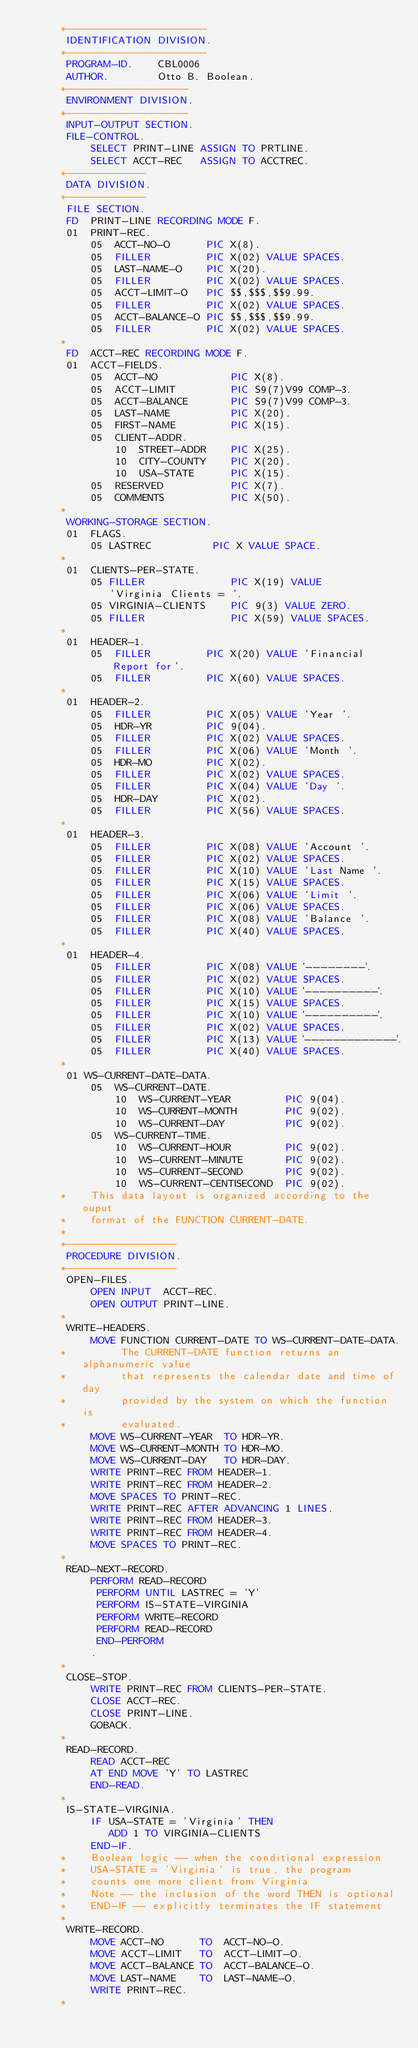Convert code to text. <code><loc_0><loc_0><loc_500><loc_500><_COBOL_>      *-----------------------
       IDENTIFICATION DIVISION.
      *-----------------------
       PROGRAM-ID.    CBL0006
       AUTHOR.        Otto B. Boolean.
      *--------------------
       ENVIRONMENT DIVISION.
      *--------------------
       INPUT-OUTPUT SECTION.
       FILE-CONTROL.
           SELECT PRINT-LINE ASSIGN TO PRTLINE.
           SELECT ACCT-REC   ASSIGN TO ACCTREC.
      *-------------
       DATA DIVISION.
      *-------------
       FILE SECTION.
       FD  PRINT-LINE RECORDING MODE F.
       01  PRINT-REC.
           05  ACCT-NO-O      PIC X(8).
           05  FILLER         PIC X(02) VALUE SPACES.
           05  LAST-NAME-O    PIC X(20).
           05  FILLER         PIC X(02) VALUE SPACES.
           05  ACCT-LIMIT-O   PIC $$,$$$,$$9.99.
           05  FILLER         PIC X(02) VALUE SPACES.
           05  ACCT-BALANCE-O PIC $$,$$$,$$9.99.
           05  FILLER         PIC X(02) VALUE SPACES.
      *
       FD  ACCT-REC RECORDING MODE F.
       01  ACCT-FIELDS.
           05  ACCT-NO            PIC X(8).
           05  ACCT-LIMIT         PIC S9(7)V99 COMP-3.
           05  ACCT-BALANCE       PIC S9(7)V99 COMP-3.
           05  LAST-NAME          PIC X(20).
           05  FIRST-NAME         PIC X(15).
           05  CLIENT-ADDR.
               10  STREET-ADDR    PIC X(25).
               10  CITY-COUNTY    PIC X(20).
               10  USA-STATE      PIC X(15).
           05  RESERVED           PIC X(7).
           05  COMMENTS           PIC X(50).
      *
       WORKING-STORAGE SECTION.
       01  FLAGS.
           05 LASTREC          PIC X VALUE SPACE.
      *
       01  CLIENTS-PER-STATE.
           05 FILLER              PIC X(19) VALUE
              'Virginia Clients = '.
           05 VIRGINIA-CLIENTS    PIC 9(3) VALUE ZERO.
           05 FILLER              PIC X(59) VALUE SPACES.
      *
       01  HEADER-1.
           05  FILLER         PIC X(20) VALUE 'Financial Report for'.
           05  FILLER         PIC X(60) VALUE SPACES.
      *
       01  HEADER-2.
           05  FILLER         PIC X(05) VALUE 'Year '.
           05  HDR-YR         PIC 9(04).
           05  FILLER         PIC X(02) VALUE SPACES.
           05  FILLER         PIC X(06) VALUE 'Month '.
           05  HDR-MO         PIC X(02).
           05  FILLER         PIC X(02) VALUE SPACES.
           05  FILLER         PIC X(04) VALUE 'Day '.
           05  HDR-DAY        PIC X(02).
           05  FILLER         PIC X(56) VALUE SPACES.
      *
       01  HEADER-3.
           05  FILLER         PIC X(08) VALUE 'Account '.
           05  FILLER         PIC X(02) VALUE SPACES.
           05  FILLER         PIC X(10) VALUE 'Last Name '.
           05  FILLER         PIC X(15) VALUE SPACES.
           05  FILLER         PIC X(06) VALUE 'Limit '.
           05  FILLER         PIC X(06) VALUE SPACES.
           05  FILLER         PIC X(08) VALUE 'Balance '.
           05  FILLER         PIC X(40) VALUE SPACES.
      *
       01  HEADER-4.
           05  FILLER         PIC X(08) VALUE '--------'.
           05  FILLER         PIC X(02) VALUE SPACES.
           05  FILLER         PIC X(10) VALUE '----------'.
           05  FILLER         PIC X(15) VALUE SPACES.
           05  FILLER         PIC X(10) VALUE '----------'.
           05  FILLER         PIC X(02) VALUE SPACES.
           05  FILLER         PIC X(13) VALUE '-------------'.
           05  FILLER         PIC X(40) VALUE SPACES.
      *
       01 WS-CURRENT-DATE-DATA.
           05  WS-CURRENT-DATE.
               10  WS-CURRENT-YEAR         PIC 9(04).
               10  WS-CURRENT-MONTH        PIC 9(02).
               10  WS-CURRENT-DAY          PIC 9(02).
           05  WS-CURRENT-TIME.
               10  WS-CURRENT-HOUR         PIC 9(02).
               10  WS-CURRENT-MINUTE       PIC 9(02).
               10  WS-CURRENT-SECOND       PIC 9(02).
               10  WS-CURRENT-CENTISECOND  PIC 9(02).
      *    This data layout is organized according to the ouput
      *    format of the FUNCTION CURRENT-DATE.
      *
      *------------------
       PROCEDURE DIVISION.
      *------------------
       OPEN-FILES.
           OPEN INPUT  ACCT-REC.
           OPEN OUTPUT PRINT-LINE.
      *
       WRITE-HEADERS.
           MOVE FUNCTION CURRENT-DATE TO WS-CURRENT-DATE-DATA.
      *         The CURRENT-DATE function returns an alphanumeric value
      *         that represents the calendar date and time of day
      *         provided by the system on which the function is
      *         evaluated.    
           MOVE WS-CURRENT-YEAR  TO HDR-YR.
           MOVE WS-CURRENT-MONTH TO HDR-MO.
           MOVE WS-CURRENT-DAY   TO HDR-DAY.
           WRITE PRINT-REC FROM HEADER-1.
           WRITE PRINT-REC FROM HEADER-2.
           MOVE SPACES TO PRINT-REC.
           WRITE PRINT-REC AFTER ADVANCING 1 LINES.
           WRITE PRINT-REC FROM HEADER-3.
           WRITE PRINT-REC FROM HEADER-4.
           MOVE SPACES TO PRINT-REC.
      *
       READ-NEXT-RECORD.
           PERFORM READ-RECORD
            PERFORM UNTIL LASTREC = 'Y'
            PERFORM IS-STATE-VIRGINIA
            PERFORM WRITE-RECORD
            PERFORM READ-RECORD
            END-PERFORM
           .
      *
       CLOSE-STOP.
           WRITE PRINT-REC FROM CLIENTS-PER-STATE.
           CLOSE ACCT-REC.
           CLOSE PRINT-LINE.
           GOBACK.
      *
       READ-RECORD.
           READ ACCT-REC
           AT END MOVE 'Y' TO LASTREC
           END-READ.
      *
       IS-STATE-VIRGINIA.
           IF USA-STATE = 'Virginia' THEN
              ADD 1 TO VIRGINIA-CLIENTS
           END-IF.
      *    Boolean logic -- when the conditional expression 
      *    USA-STATE = 'Virginia' is true, the program
      *    counts one more client from Virginia
      *    Note -- the inclusion of the word THEN is optional
      *    END-IF -- explicitly terminates the IF statement 
      *
       WRITE-RECORD.
           MOVE ACCT-NO      TO  ACCT-NO-O.
           MOVE ACCT-LIMIT   TO  ACCT-LIMIT-O.
           MOVE ACCT-BALANCE TO  ACCT-BALANCE-O.
           MOVE LAST-NAME    TO  LAST-NAME-O.
           WRITE PRINT-REC.
      *
</code> 